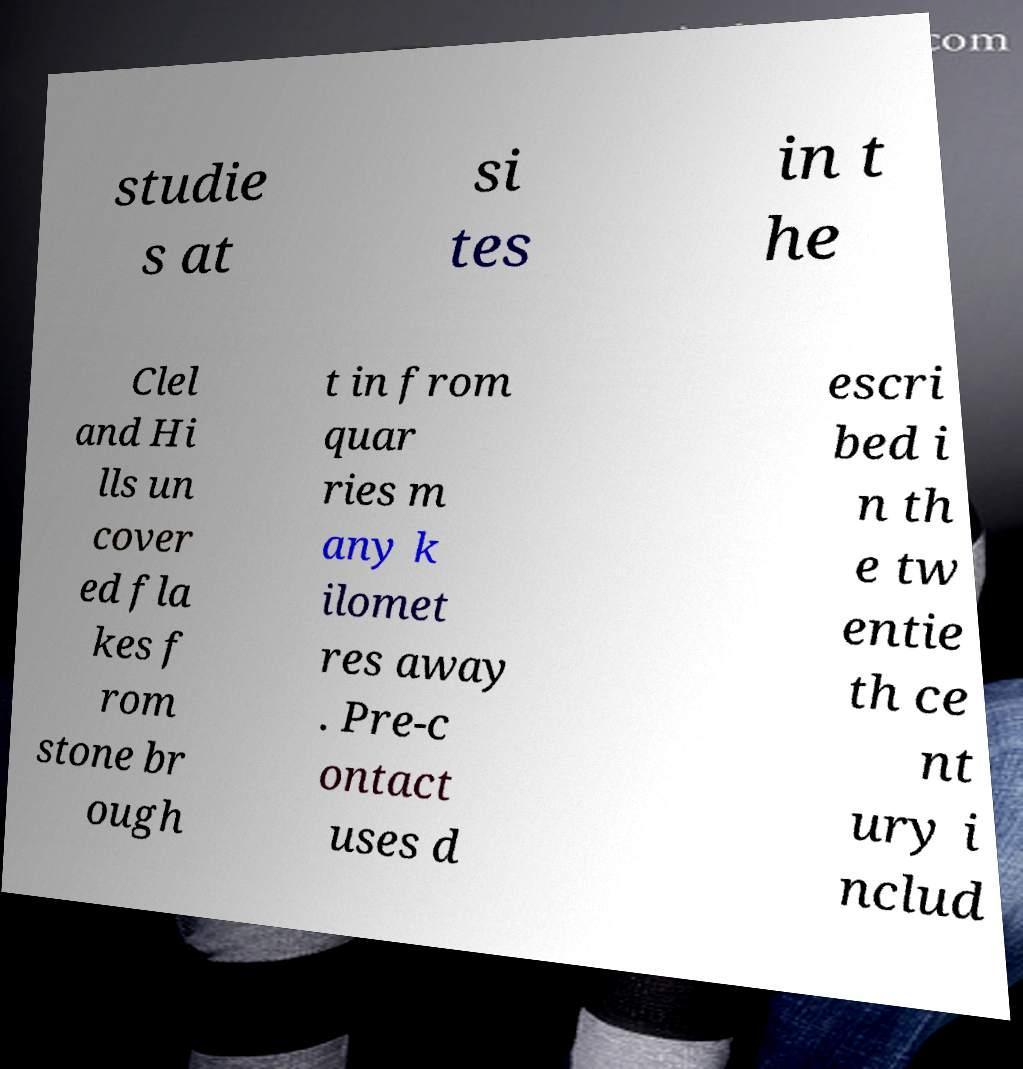Please read and relay the text visible in this image. What does it say? studie s at si tes in t he Clel and Hi lls un cover ed fla kes f rom stone br ough t in from quar ries m any k ilomet res away . Pre-c ontact uses d escri bed i n th e tw entie th ce nt ury i nclud 